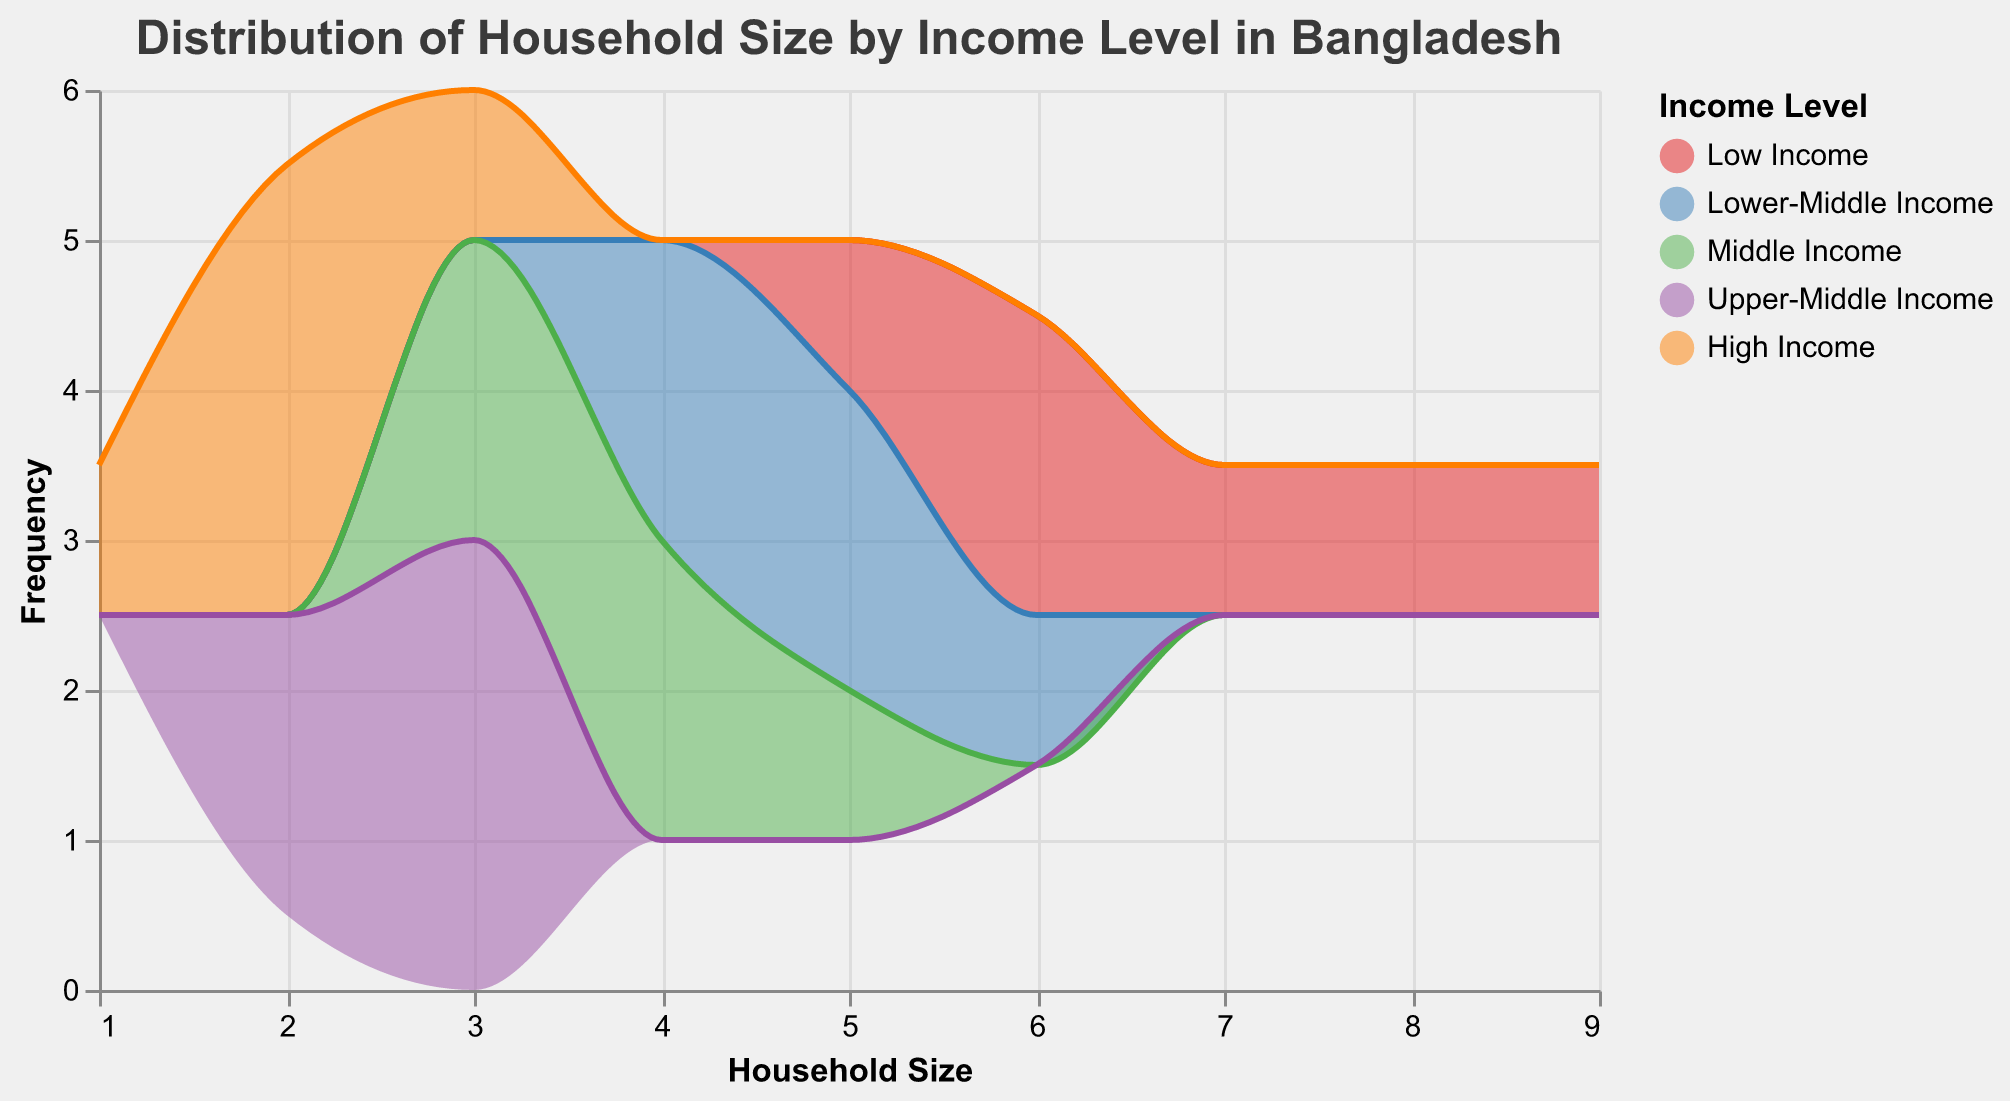What is the title of the plot? The title of a plot is usually displayed at the top of the figure and it provides a brief description of the data being visualized. Here, the title is written at the top center.
Answer: Distribution of Household Size by Income Level in Bangladesh How many socio-economic strata are represented in this plot? Different distributions are typically represented by different colors in the plot. By observing the legend or the color-coded areas/lines, you can count the number of strata.
Answer: Five Which household income group has the largest household size? The data points for household sizes are plotted on the x-axis; by looking at the peaks in the plotted areas/lines, we can determine which group has households with larger sizes. The highest peak of the largest household size belongs to Low-Income strata.
Answer: Low Income What is the color representation for the Lower-Middle Income group? Referring to the color legend on the right side of the plot, you can identify the color associated with each socio-economic stratum.
Answer: Blue What is the most common household size in the Upper-Middle Income group? To find the most common household size, look for the highest peak in the area or line corresponding to the Upper-Middle Income group.
Answer: 3 Which income level group shows the smallest average household size? By observing where the peak of each income group is located on the x-axis, we can determine the household size for each group. The High-income group has peaks around household sizes of 2 and 1.
Answer: High Income What is the range of household sizes covered in this plot? The x-axis represents household sizes. The minimum and maximum values on this axis give the range.
Answer: 1 to 9 What is the average household size for the Middle Income group? Identify all the data points for the Middle Income group, sum them up, and divide by the number of points. (4+3+5+4+3)/5 = 19/5 = 3.8
Answer: 3.8 Compare the frequency of household sizes 2 and 5 across all income groups. Which size is more common? Count the occurrences of household sizes 2 and 5 in the plotted data. Household size 2 has peaks for Upper-Middle and High-Income groups, while household size 5 has peaks for Lower-Middle and Middle Income. Size 2 peaks more frequently.
Answer: Size 2 How does the household size distribution of Low Income compare to High Income? By comparing the shapes and sizes of the areas/lines for both Low and High Income groups, we can infer the distribution differences. Low Income has higher frequencies with larger peaks around sizes 5, 6, 7, and 9, while High Income peaks around sizes 1, 2, and 3 with smaller overall household sizes.
Answer: Low Income has larger household sizes 